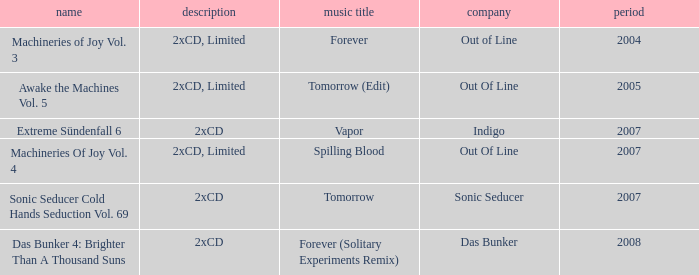What average year contains the title of machineries of joy vol. 4? 2007.0. 